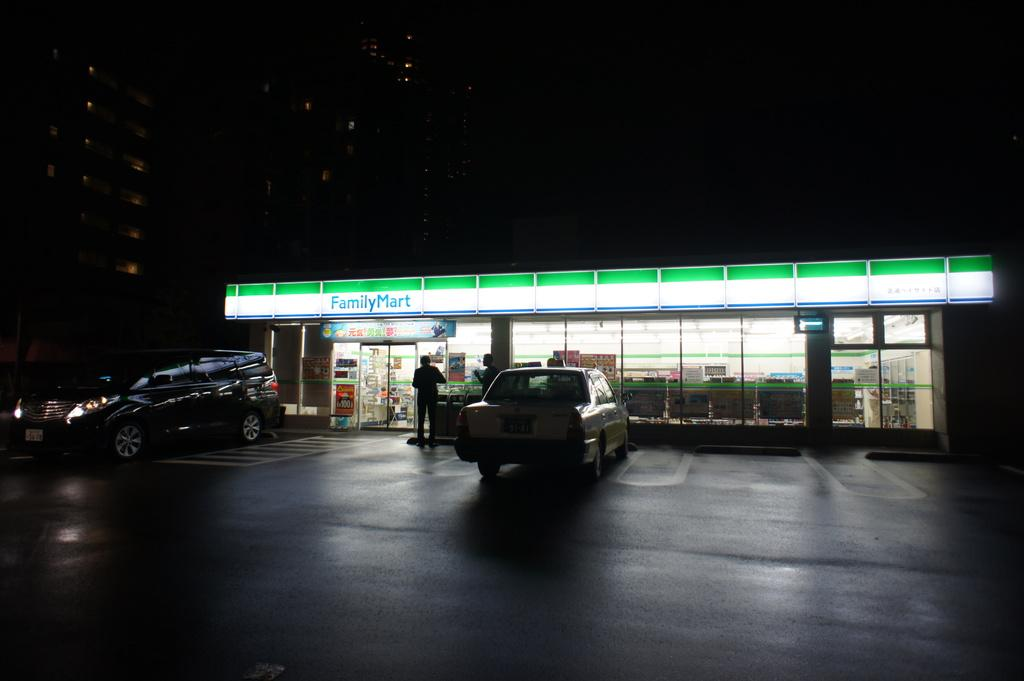<image>
Describe the image concisely. FamilyMart is open late and has a few patrons. 